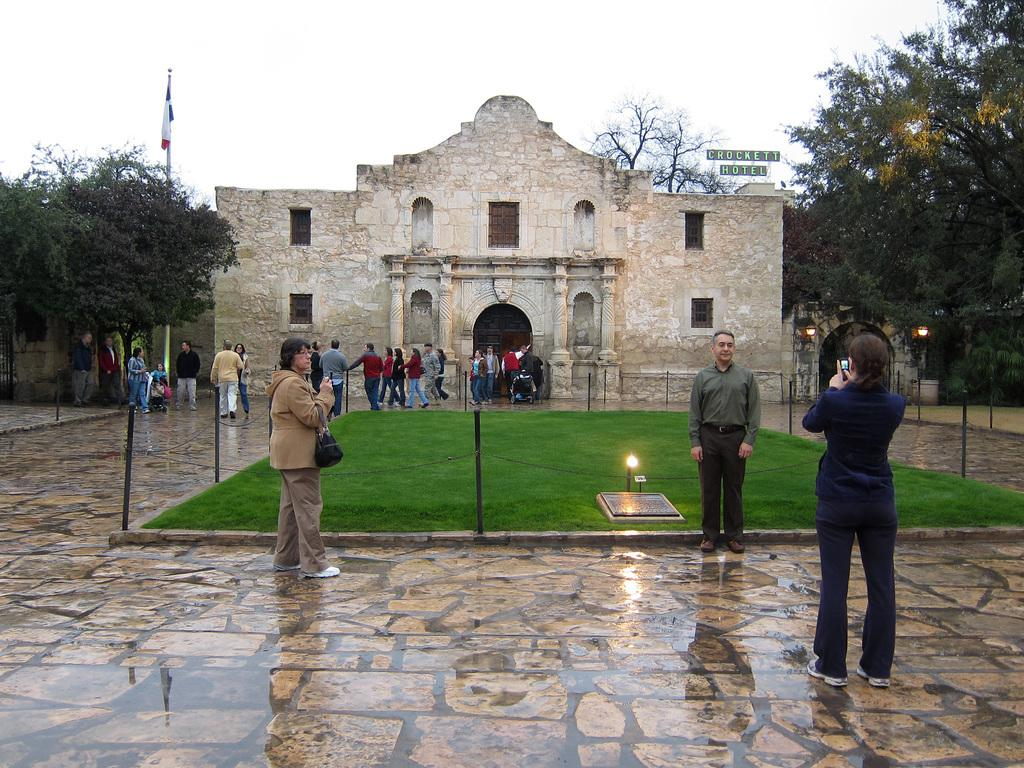How many people are in the image? There are people in the image, but the exact number is not specified. What objects are present in the image that are used for support or suspension? Poles and chains are present in the image for support or suspension. What can be used for illumination in the image? Lights are visible in the image for illumination. What objects are present in the image that can be used for displaying information or advertisements? Boards are in the image for displaying information or advertisements. What is the symbolic object present in the image? There is a flag in the image, which is a symbolic object. What type of vegetation is present in the image? Trees are present in the image. What type of structure is visible in the image? There is a building in the image. What is visible in the background of the image? The sky is visible in the background of the image. What type of texture can be seen on the pan in the image? There is no pan present in the image, so it is not possible to describe its texture. What shape is the square object in the image? There is no square object present in the image. 